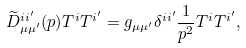Convert formula to latex. <formula><loc_0><loc_0><loc_500><loc_500>\widetilde { D } ^ { i i ^ { \prime } } _ { \mu \mu ^ { \prime } } ( p ) T ^ { i } T ^ { i ^ { \prime } } = g _ { \mu \mu ^ { \prime } } \delta ^ { i i ^ { \prime } } \frac { 1 } { p ^ { 2 } } T ^ { i } T ^ { i ^ { \prime } } ,</formula> 